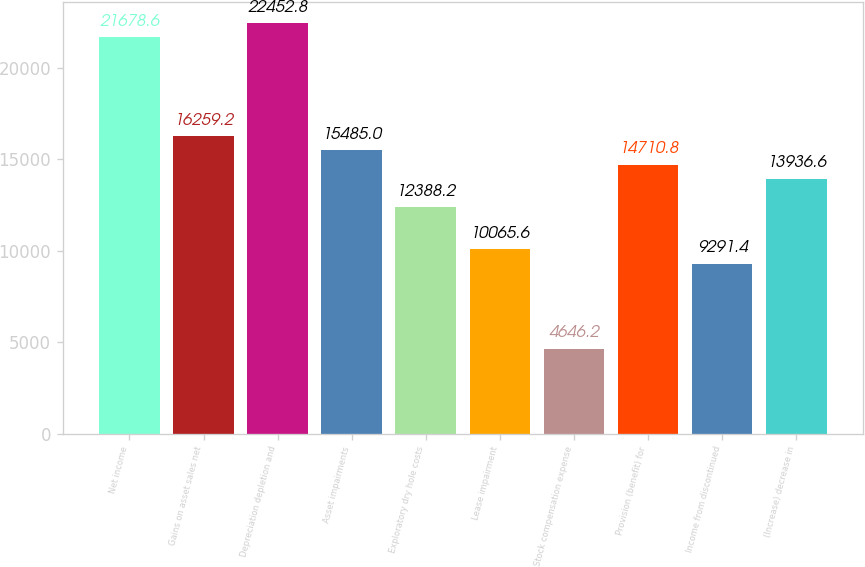Convert chart. <chart><loc_0><loc_0><loc_500><loc_500><bar_chart><fcel>Net income<fcel>Gains on asset sales net<fcel>Depreciation depletion and<fcel>Asset impairments<fcel>Exploratory dry hole costs<fcel>Lease impairment<fcel>Stock compensation expense<fcel>Provision (benefit) for<fcel>Income from discontinued<fcel>(Increase) decrease in<nl><fcel>21678.6<fcel>16259.2<fcel>22452.8<fcel>15485<fcel>12388.2<fcel>10065.6<fcel>4646.2<fcel>14710.8<fcel>9291.4<fcel>13936.6<nl></chart> 